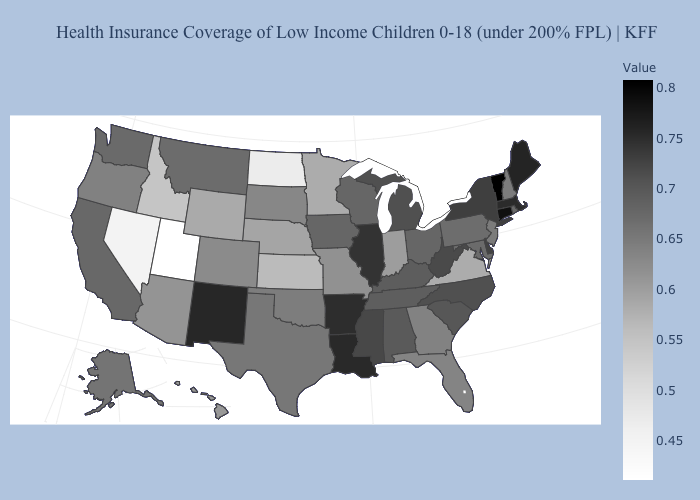Among the states that border Nevada , does Arizona have the lowest value?
Give a very brief answer. No. Which states have the lowest value in the USA?
Give a very brief answer. Utah. Does Vermont have the highest value in the USA?
Keep it brief. Yes. Does Pennsylvania have a higher value than Mississippi?
Keep it brief. No. Which states have the lowest value in the MidWest?
Quick response, please. North Dakota. Does the map have missing data?
Answer briefly. No. Among the states that border Vermont , which have the lowest value?
Concise answer only. New Hampshire. 